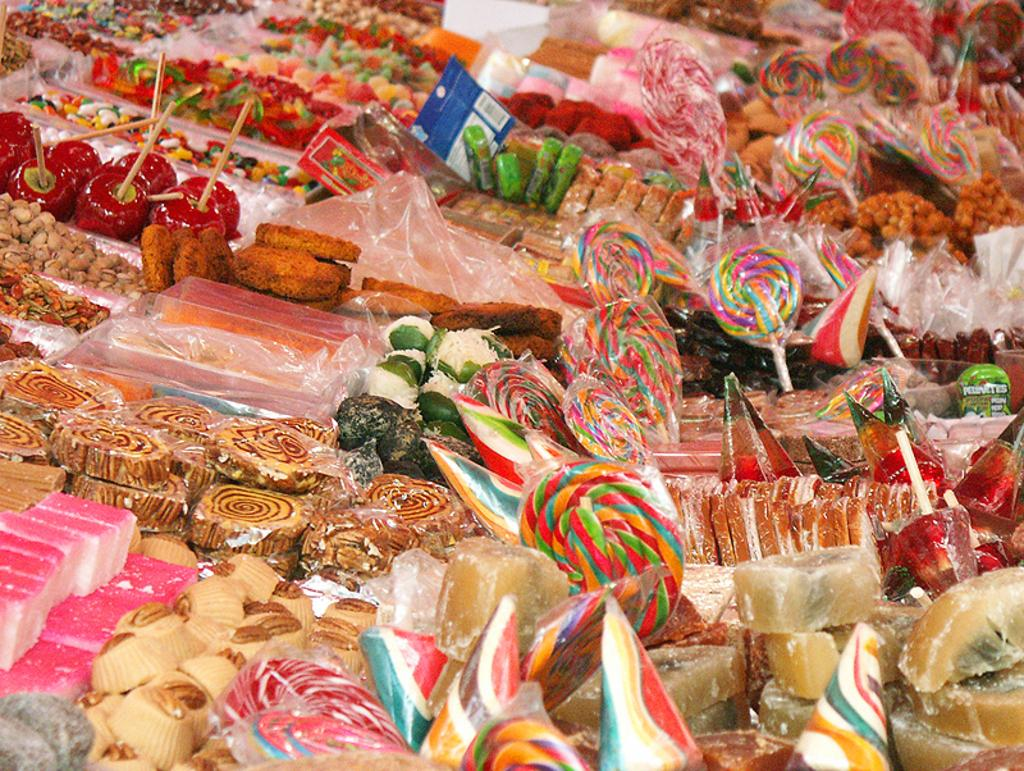What type of food items can be seen in the image? There are candies and other baked food items in the image. Can you describe the baked food items in the image? Unfortunately, the provided facts do not specify the type of baked food items in the image. Are there any other food items or objects visible in the image? No additional food items or objects are mentioned in the provided facts. What type of yarn is being used to create the candies in the image? There is no yarn present in the image, as the provided facts only mention candies and other baked food items. 